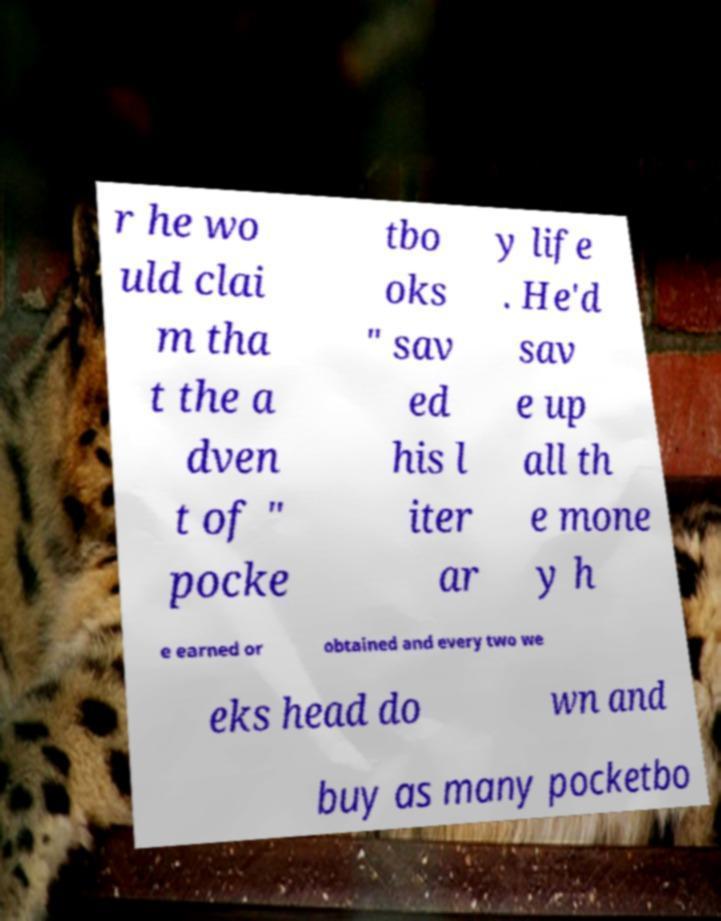Could you assist in decoding the text presented in this image and type it out clearly? r he wo uld clai m tha t the a dven t of " pocke tbo oks " sav ed his l iter ar y life . He'd sav e up all th e mone y h e earned or obtained and every two we eks head do wn and buy as many pocketbo 